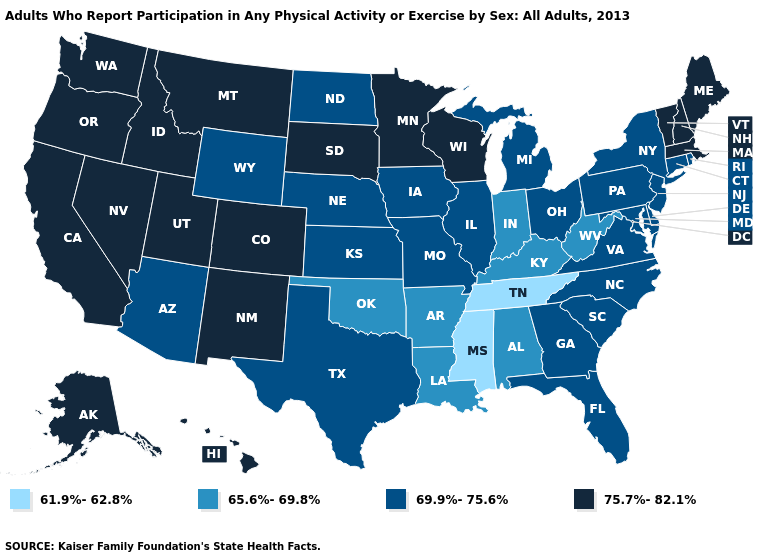How many symbols are there in the legend?
Short answer required. 4. Which states hav the highest value in the South?
Give a very brief answer. Delaware, Florida, Georgia, Maryland, North Carolina, South Carolina, Texas, Virginia. Name the states that have a value in the range 75.7%-82.1%?
Keep it brief. Alaska, California, Colorado, Hawaii, Idaho, Maine, Massachusetts, Minnesota, Montana, Nevada, New Hampshire, New Mexico, Oregon, South Dakota, Utah, Vermont, Washington, Wisconsin. What is the value of North Carolina?
Give a very brief answer. 69.9%-75.6%. What is the value of Oregon?
Keep it brief. 75.7%-82.1%. What is the value of Maine?
Be succinct. 75.7%-82.1%. Among the states that border North Carolina , which have the highest value?
Be succinct. Georgia, South Carolina, Virginia. Name the states that have a value in the range 61.9%-62.8%?
Give a very brief answer. Mississippi, Tennessee. Does the map have missing data?
Give a very brief answer. No. Which states have the lowest value in the USA?
Quick response, please. Mississippi, Tennessee. What is the value of West Virginia?
Concise answer only. 65.6%-69.8%. Name the states that have a value in the range 61.9%-62.8%?
Answer briefly. Mississippi, Tennessee. What is the value of Connecticut?
Short answer required. 69.9%-75.6%. What is the value of Vermont?
Short answer required. 75.7%-82.1%. Name the states that have a value in the range 61.9%-62.8%?
Give a very brief answer. Mississippi, Tennessee. 